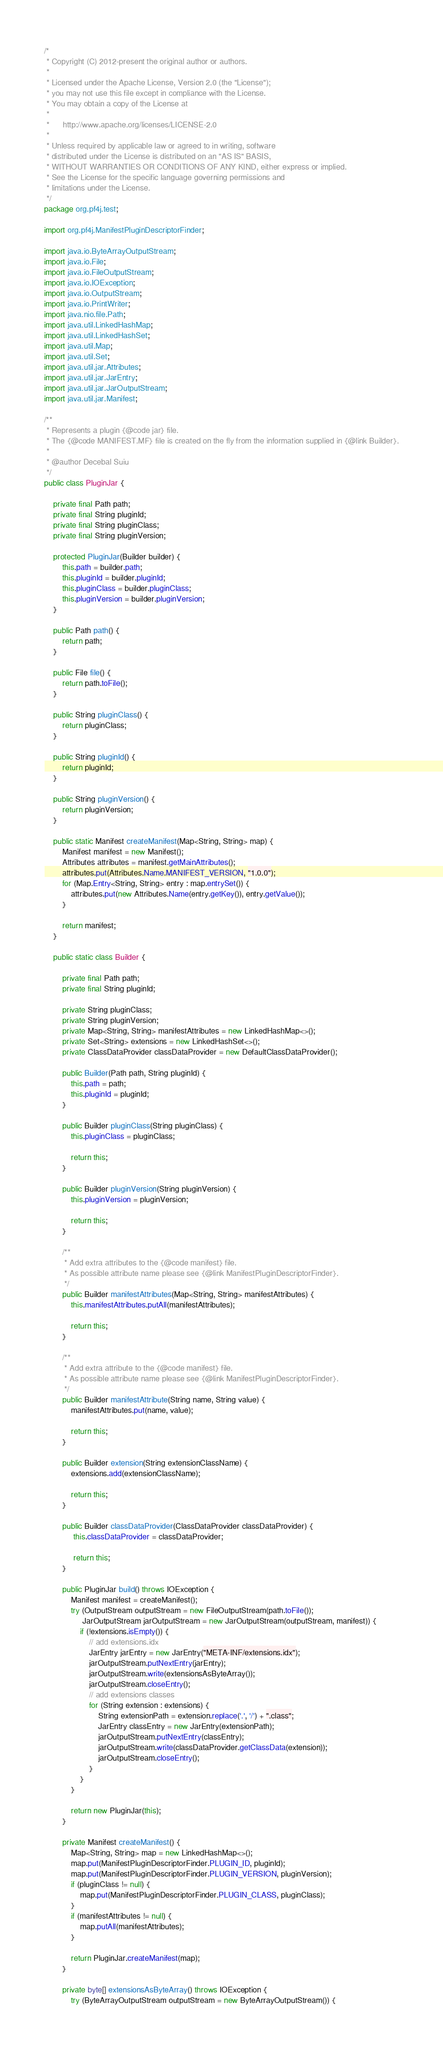Convert code to text. <code><loc_0><loc_0><loc_500><loc_500><_Java_>/*
 * Copyright (C) 2012-present the original author or authors.
 *
 * Licensed under the Apache License, Version 2.0 (the "License");
 * you may not use this file except in compliance with the License.
 * You may obtain a copy of the License at
 *
 *      http://www.apache.org/licenses/LICENSE-2.0
 *
 * Unless required by applicable law or agreed to in writing, software
 * distributed under the License is distributed on an "AS IS" BASIS,
 * WITHOUT WARRANTIES OR CONDITIONS OF ANY KIND, either express or implied.
 * See the License for the specific language governing permissions and
 * limitations under the License.
 */
package org.pf4j.test;

import org.pf4j.ManifestPluginDescriptorFinder;

import java.io.ByteArrayOutputStream;
import java.io.File;
import java.io.FileOutputStream;
import java.io.IOException;
import java.io.OutputStream;
import java.io.PrintWriter;
import java.nio.file.Path;
import java.util.LinkedHashMap;
import java.util.LinkedHashSet;
import java.util.Map;
import java.util.Set;
import java.util.jar.Attributes;
import java.util.jar.JarEntry;
import java.util.jar.JarOutputStream;
import java.util.jar.Manifest;

/**
 * Represents a plugin {@code jar} file.
 * The {@code MANIFEST.MF} file is created on the fly from the information supplied in {@link Builder}.
 *
 * @author Decebal Suiu
 */
public class PluginJar {

    private final Path path;
    private final String pluginId;
    private final String pluginClass;
    private final String pluginVersion;

    protected PluginJar(Builder builder) {
        this.path = builder.path;
        this.pluginId = builder.pluginId;
        this.pluginClass = builder.pluginClass;
        this.pluginVersion = builder.pluginVersion;
    }

    public Path path() {
        return path;
    }

    public File file() {
        return path.toFile();
    }

    public String pluginClass() {
        return pluginClass;
    }

    public String pluginId() {
        return pluginId;
    }

    public String pluginVersion() {
        return pluginVersion;
    }

    public static Manifest createManifest(Map<String, String> map) {
        Manifest manifest = new Manifest();
        Attributes attributes = manifest.getMainAttributes();
        attributes.put(Attributes.Name.MANIFEST_VERSION, "1.0.0");
        for (Map.Entry<String, String> entry : map.entrySet()) {
            attributes.put(new Attributes.Name(entry.getKey()), entry.getValue());
        }

        return manifest;
    }

    public static class Builder {

        private final Path path;
        private final String pluginId;

        private String pluginClass;
        private String pluginVersion;
        private Map<String, String> manifestAttributes = new LinkedHashMap<>();
        private Set<String> extensions = new LinkedHashSet<>();
        private ClassDataProvider classDataProvider = new DefaultClassDataProvider();

        public Builder(Path path, String pluginId) {
            this.path = path;
            this.pluginId = pluginId;
        }

        public Builder pluginClass(String pluginClass) {
            this.pluginClass = pluginClass;

            return this;
        }

        public Builder pluginVersion(String pluginVersion) {
            this.pluginVersion = pluginVersion;

            return this;
        }

        /**
         * Add extra attributes to the {@code manifest} file.
         * As possible attribute name please see {@link ManifestPluginDescriptorFinder}.
         */
        public Builder manifestAttributes(Map<String, String> manifestAttributes) {
            this.manifestAttributes.putAll(manifestAttributes);

            return this;
        }

        /**
         * Add extra attribute to the {@code manifest} file.
         * As possible attribute name please see {@link ManifestPluginDescriptorFinder}.
         */
        public Builder manifestAttribute(String name, String value) {
            manifestAttributes.put(name, value);

            return this;
        }

        public Builder extension(String extensionClassName) {
            extensions.add(extensionClassName);

            return this;
        }

        public Builder classDataProvider(ClassDataProvider classDataProvider) {
             this.classDataProvider = classDataProvider;

             return this;
        }

        public PluginJar build() throws IOException {
            Manifest manifest = createManifest();
            try (OutputStream outputStream = new FileOutputStream(path.toFile());
                 JarOutputStream jarOutputStream = new JarOutputStream(outputStream, manifest)) {
                if (!extensions.isEmpty()) {
                    // add extensions.idx
                    JarEntry jarEntry = new JarEntry("META-INF/extensions.idx");
                    jarOutputStream.putNextEntry(jarEntry);
                    jarOutputStream.write(extensionsAsByteArray());
                    jarOutputStream.closeEntry();
                    // add extensions classes
                    for (String extension : extensions) {
                        String extensionPath = extension.replace('.', '/') + ".class";
                        JarEntry classEntry = new JarEntry(extensionPath);
                        jarOutputStream.putNextEntry(classEntry);
                        jarOutputStream.write(classDataProvider.getClassData(extension));
                        jarOutputStream.closeEntry();
                    }
                }
            }

            return new PluginJar(this);
        }

        private Manifest createManifest() {
            Map<String, String> map = new LinkedHashMap<>();
            map.put(ManifestPluginDescriptorFinder.PLUGIN_ID, pluginId);
            map.put(ManifestPluginDescriptorFinder.PLUGIN_VERSION, pluginVersion);
            if (pluginClass != null) {
                map.put(ManifestPluginDescriptorFinder.PLUGIN_CLASS, pluginClass);
            }
            if (manifestAttributes != null) {
                map.putAll(manifestAttributes);
            }

            return PluginJar.createManifest(map);
        }

        private byte[] extensionsAsByteArray() throws IOException {
            try (ByteArrayOutputStream outputStream = new ByteArrayOutputStream()) {</code> 